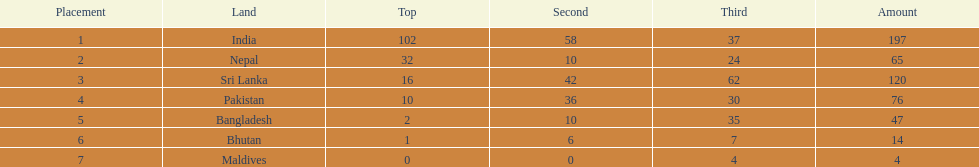What is the difference between the nation with the most medals and the nation with the least amount of medals? 193. 